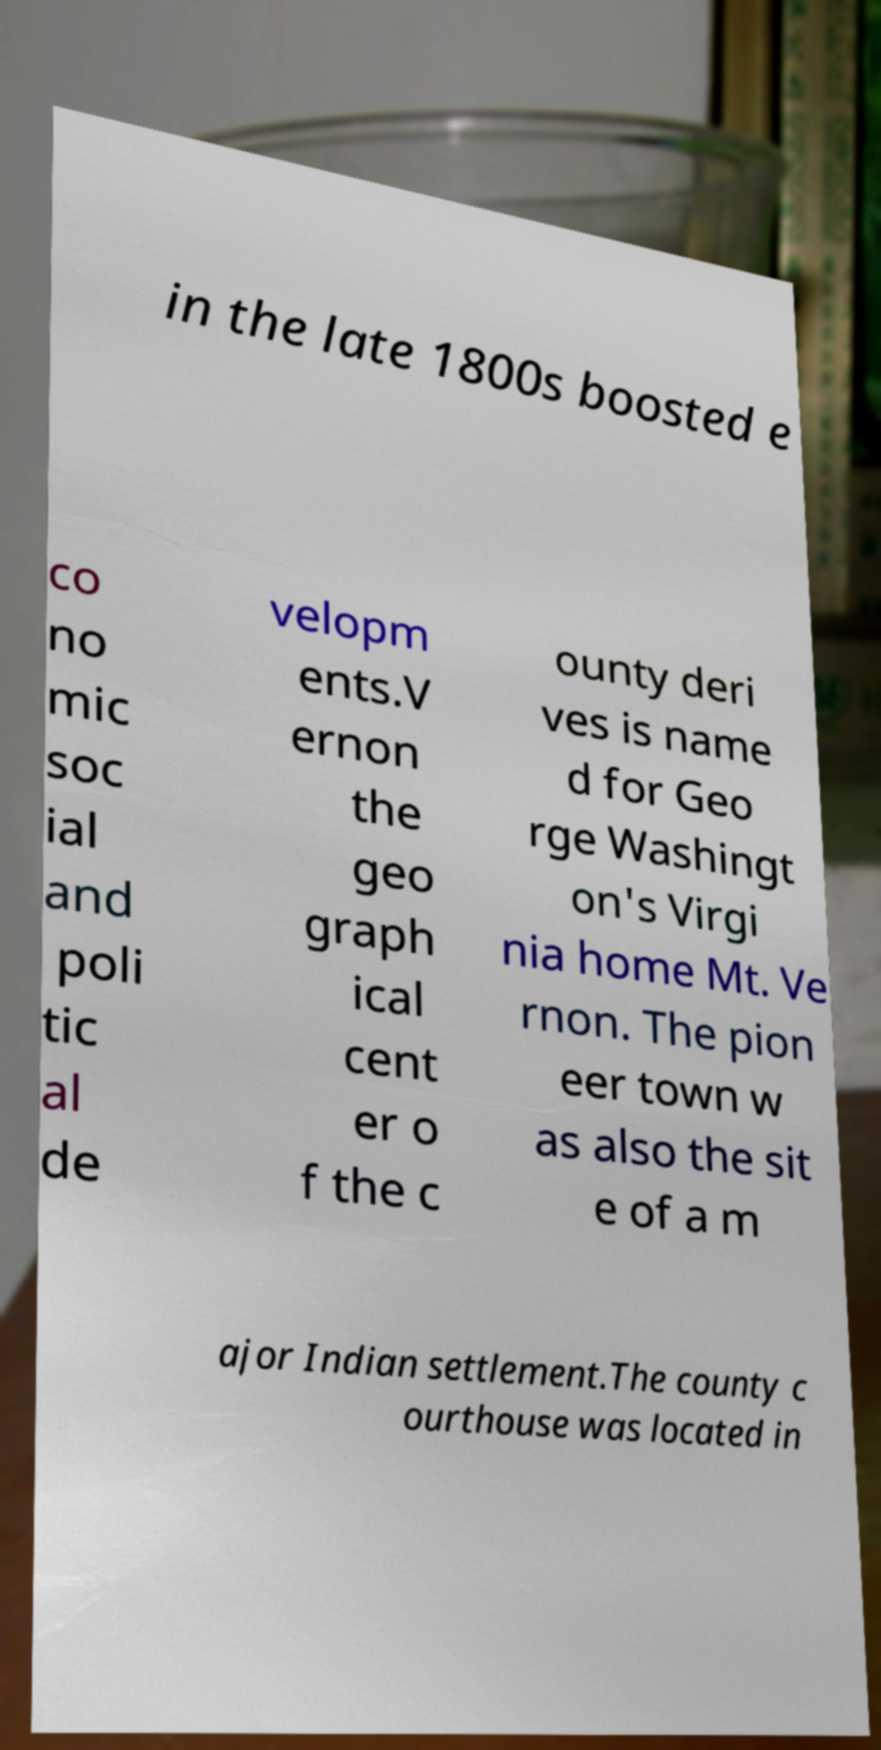What messages or text are displayed in this image? I need them in a readable, typed format. in the late 1800s boosted e co no mic soc ial and poli tic al de velopm ents.V ernon the geo graph ical cent er o f the c ounty deri ves is name d for Geo rge Washingt on's Virgi nia home Mt. Ve rnon. The pion eer town w as also the sit e of a m ajor Indian settlement.The county c ourthouse was located in 